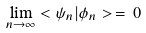<formula> <loc_0><loc_0><loc_500><loc_500>\lim _ { n \rightarrow \infty } < \psi _ { n } | \phi _ { n } > \, = \, 0</formula> 